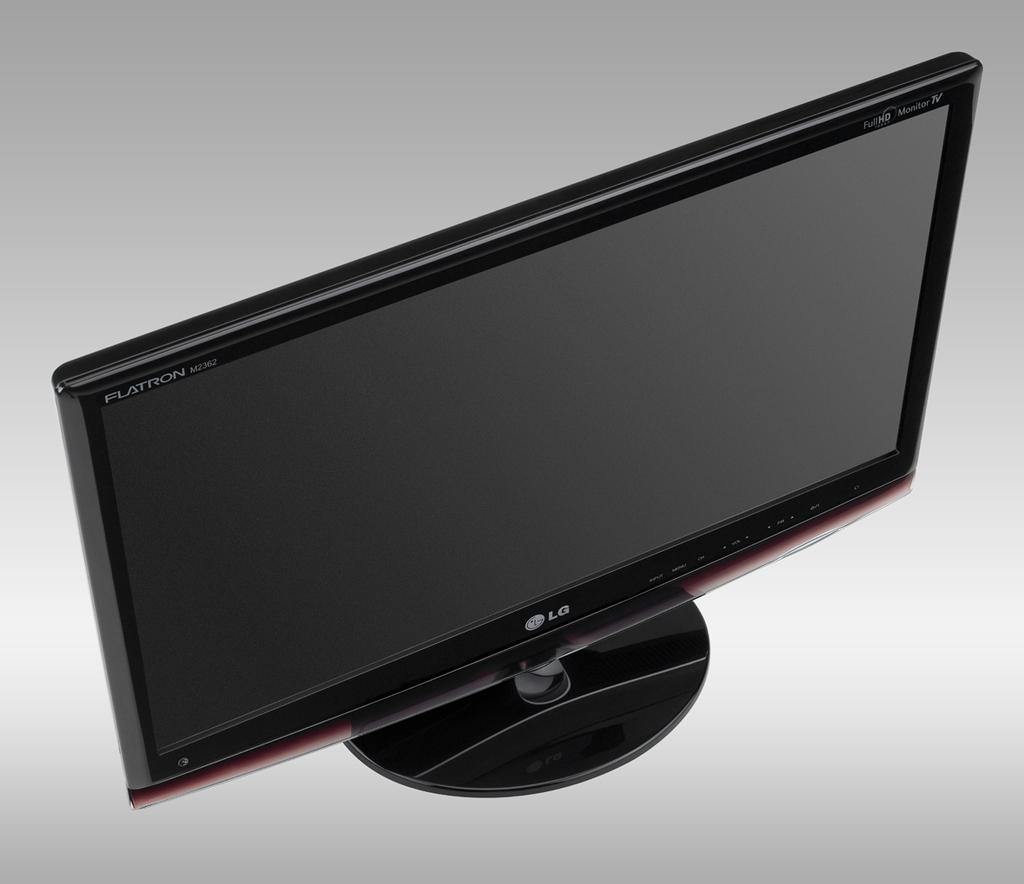<image>
Relay a brief, clear account of the picture shown. An LG monitor is on a white surface and says Flatron on the bezel. 